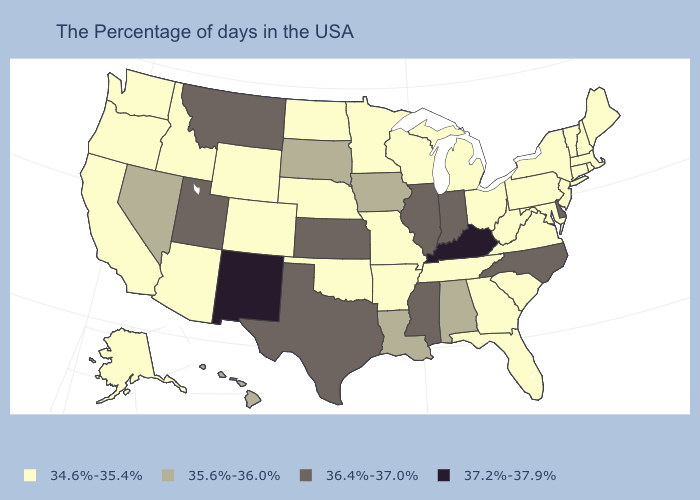Does the map have missing data?
Answer briefly. No. What is the value of North Dakota?
Concise answer only. 34.6%-35.4%. Does the map have missing data?
Answer briefly. No. What is the highest value in states that border Colorado?
Quick response, please. 37.2%-37.9%. Is the legend a continuous bar?
Short answer required. No. Which states have the lowest value in the USA?
Be succinct. Maine, Massachusetts, Rhode Island, New Hampshire, Vermont, Connecticut, New York, New Jersey, Maryland, Pennsylvania, Virginia, South Carolina, West Virginia, Ohio, Florida, Georgia, Michigan, Tennessee, Wisconsin, Missouri, Arkansas, Minnesota, Nebraska, Oklahoma, North Dakota, Wyoming, Colorado, Arizona, Idaho, California, Washington, Oregon, Alaska. Name the states that have a value in the range 37.2%-37.9%?
Keep it brief. Kentucky, New Mexico. Name the states that have a value in the range 37.2%-37.9%?
Give a very brief answer. Kentucky, New Mexico. Name the states that have a value in the range 37.2%-37.9%?
Concise answer only. Kentucky, New Mexico. What is the value of Texas?
Concise answer only. 36.4%-37.0%. Name the states that have a value in the range 34.6%-35.4%?
Quick response, please. Maine, Massachusetts, Rhode Island, New Hampshire, Vermont, Connecticut, New York, New Jersey, Maryland, Pennsylvania, Virginia, South Carolina, West Virginia, Ohio, Florida, Georgia, Michigan, Tennessee, Wisconsin, Missouri, Arkansas, Minnesota, Nebraska, Oklahoma, North Dakota, Wyoming, Colorado, Arizona, Idaho, California, Washington, Oregon, Alaska. Is the legend a continuous bar?
Concise answer only. No. What is the value of Arizona?
Give a very brief answer. 34.6%-35.4%. Among the states that border Florida , does Georgia have the highest value?
Concise answer only. No. What is the highest value in the USA?
Write a very short answer. 37.2%-37.9%. 